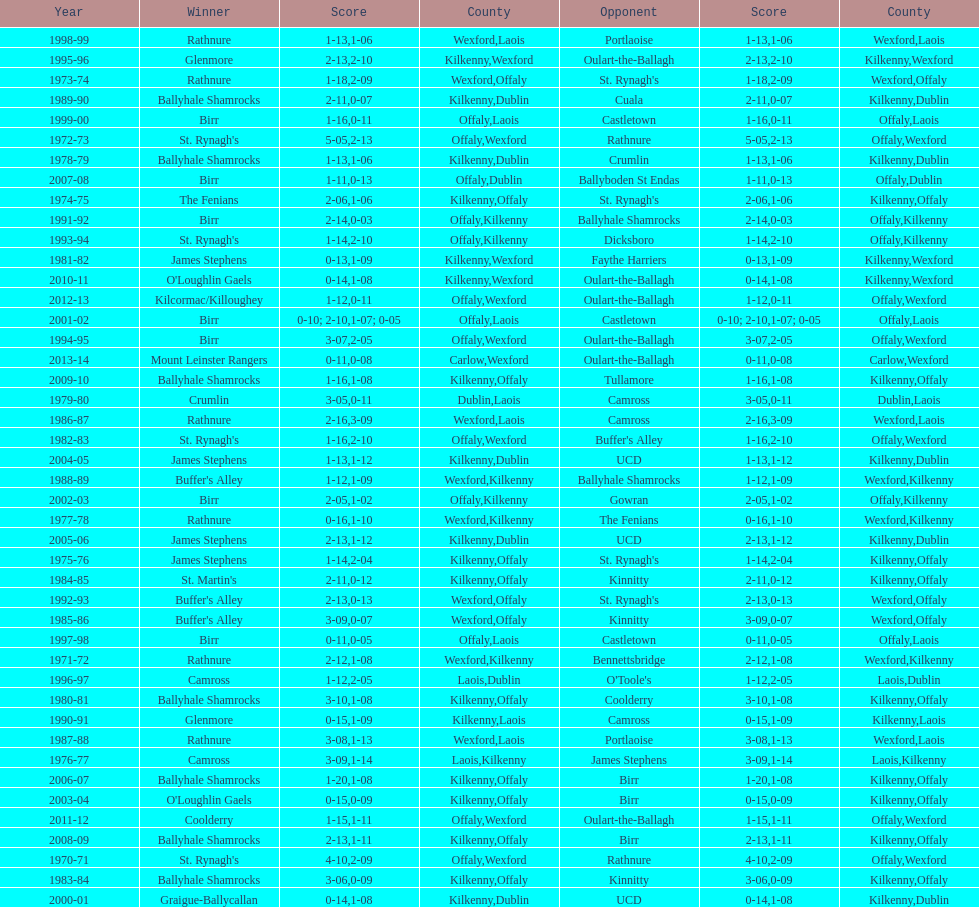Which winner is next to mount leinster rangers? Kilcormac/Killoughey. Can you give me this table as a dict? {'header': ['Year', 'Winner', 'Score', 'County', 'Opponent', 'Score', 'County'], 'rows': [['1998-99', 'Rathnure', '1-13', 'Wexford', 'Portlaoise', '1-06', 'Laois'], ['1995-96', 'Glenmore', '2-13', 'Kilkenny', 'Oulart-the-Ballagh', '2-10', 'Wexford'], ['1973-74', 'Rathnure', '1-18', 'Wexford', "St. Rynagh's", '2-09', 'Offaly'], ['1989-90', 'Ballyhale Shamrocks', '2-11', 'Kilkenny', 'Cuala', '0-07', 'Dublin'], ['1999-00', 'Birr', '1-16', 'Offaly', 'Castletown', '0-11', 'Laois'], ['1972-73', "St. Rynagh's", '5-05', 'Offaly', 'Rathnure', '2-13', 'Wexford'], ['1978-79', 'Ballyhale Shamrocks', '1-13', 'Kilkenny', 'Crumlin', '1-06', 'Dublin'], ['2007-08', 'Birr', '1-11', 'Offaly', 'Ballyboden St Endas', '0-13', 'Dublin'], ['1974-75', 'The Fenians', '2-06', 'Kilkenny', "St. Rynagh's", '1-06', 'Offaly'], ['1991-92', 'Birr', '2-14', 'Offaly', 'Ballyhale Shamrocks', '0-03', 'Kilkenny'], ['1993-94', "St. Rynagh's", '1-14', 'Offaly', 'Dicksboro', '2-10', 'Kilkenny'], ['1981-82', 'James Stephens', '0-13', 'Kilkenny', 'Faythe Harriers', '1-09', 'Wexford'], ['2010-11', "O'Loughlin Gaels", '0-14', 'Kilkenny', 'Oulart-the-Ballagh', '1-08', 'Wexford'], ['2012-13', 'Kilcormac/Killoughey', '1-12', 'Offaly', 'Oulart-the-Ballagh', '0-11', 'Wexford'], ['2001-02', 'Birr', '0-10; 2-10', 'Offaly', 'Castletown', '1-07; 0-05', 'Laois'], ['1994-95', 'Birr', '3-07', 'Offaly', 'Oulart-the-Ballagh', '2-05', 'Wexford'], ['2013-14', 'Mount Leinster Rangers', '0-11', 'Carlow', 'Oulart-the-Ballagh', '0-08', 'Wexford'], ['2009-10', 'Ballyhale Shamrocks', '1-16', 'Kilkenny', 'Tullamore', '1-08', 'Offaly'], ['1979-80', 'Crumlin', '3-05', 'Dublin', 'Camross', '0-11', 'Laois'], ['1986-87', 'Rathnure', '2-16', 'Wexford', 'Camross', '3-09', 'Laois'], ['1982-83', "St. Rynagh's", '1-16', 'Offaly', "Buffer's Alley", '2-10', 'Wexford'], ['2004-05', 'James Stephens', '1-13', 'Kilkenny', 'UCD', '1-12', 'Dublin'], ['1988-89', "Buffer's Alley", '1-12', 'Wexford', 'Ballyhale Shamrocks', '1-09', 'Kilkenny'], ['2002-03', 'Birr', '2-05', 'Offaly', 'Gowran', '1-02', 'Kilkenny'], ['1977-78', 'Rathnure', '0-16', 'Wexford', 'The Fenians', '1-10', 'Kilkenny'], ['2005-06', 'James Stephens', '2-13', 'Kilkenny', 'UCD', '1-12', 'Dublin'], ['1975-76', 'James Stephens', '1-14', 'Kilkenny', "St. Rynagh's", '2-04', 'Offaly'], ['1984-85', "St. Martin's", '2-11', 'Kilkenny', 'Kinnitty', '0-12', 'Offaly'], ['1992-93', "Buffer's Alley", '2-13', 'Wexford', "St. Rynagh's", '0-13', 'Offaly'], ['1985-86', "Buffer's Alley", '3-09', 'Wexford', 'Kinnitty', '0-07', 'Offaly'], ['1997-98', 'Birr', '0-11', 'Offaly', 'Castletown', '0-05', 'Laois'], ['1971-72', 'Rathnure', '2-12', 'Wexford', 'Bennettsbridge', '1-08', 'Kilkenny'], ['1996-97', 'Camross', '1-12', 'Laois', "O'Toole's", '2-05', 'Dublin'], ['1980-81', 'Ballyhale Shamrocks', '3-10', 'Kilkenny', 'Coolderry', '1-08', 'Offaly'], ['1990-91', 'Glenmore', '0-15', 'Kilkenny', 'Camross', '1-09', 'Laois'], ['1987-88', 'Rathnure', '3-08', 'Wexford', 'Portlaoise', '1-13', 'Laois'], ['1976-77', 'Camross', '3-09', 'Laois', 'James Stephens', '1-14', 'Kilkenny'], ['2006-07', 'Ballyhale Shamrocks', '1-20', 'Kilkenny', 'Birr', '1-08', 'Offaly'], ['2003-04', "O'Loughlin Gaels", '0-15', 'Kilkenny', 'Birr', '0-09', 'Offaly'], ['2011-12', 'Coolderry', '1-15', 'Offaly', 'Oulart-the-Ballagh', '1-11', 'Wexford'], ['2008-09', 'Ballyhale Shamrocks', '2-13', 'Kilkenny', 'Birr', '1-11', 'Offaly'], ['1970-71', "St. Rynagh's", '4-10', 'Offaly', 'Rathnure', '2-09', 'Wexford'], ['1983-84', 'Ballyhale Shamrocks', '3-06', 'Kilkenny', 'Kinnitty', '0-09', 'Offaly'], ['2000-01', 'Graigue-Ballycallan', '0-14', 'Kilkenny', 'UCD', '1-08', 'Dublin']]} 